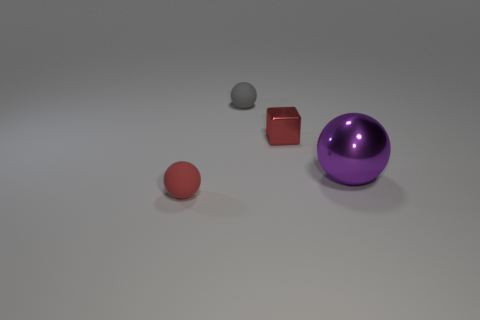Subtract all tiny balls. How many balls are left? 1 Add 1 big red cylinders. How many objects exist? 5 Subtract all purple spheres. How many spheres are left? 2 Subtract 2 balls. How many balls are left? 1 Subtract all cubes. How many objects are left? 3 Subtract 1 red spheres. How many objects are left? 3 Subtract all yellow blocks. Subtract all green cylinders. How many blocks are left? 1 Subtract all small objects. Subtract all tiny green metallic objects. How many objects are left? 1 Add 1 tiny red matte spheres. How many tiny red matte spheres are left? 2 Add 3 large brown rubber spheres. How many large brown rubber spheres exist? 3 